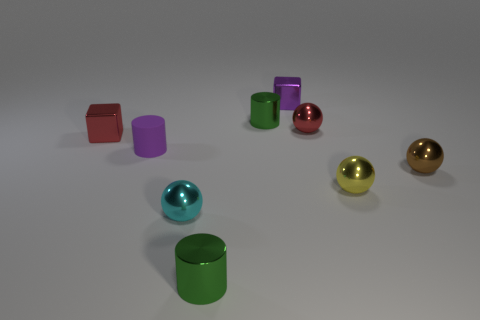Does the small matte object have the same color as the small ball behind the purple cylinder?
Provide a short and direct response. No. What color is the small ball that is in front of the brown ball and left of the yellow object?
Give a very brief answer. Cyan. There is a purple metal cube; what number of small red metal things are behind it?
Provide a short and direct response. 0. How many things are either large blocks or red spheres behind the cyan sphere?
Your answer should be compact. 1. Is there a small green object in front of the tiny cyan thing in front of the small rubber cylinder?
Keep it short and to the point. Yes. What is the color of the tiny cylinder that is in front of the tiny brown sphere?
Your response must be concise. Green. Is the number of tiny brown objects behind the small matte cylinder the same as the number of red metal things?
Your response must be concise. No. There is a small metal thing that is behind the brown metallic thing and in front of the tiny red metallic sphere; what is its shape?
Provide a succinct answer. Cube. There is another small metal object that is the same shape as the small purple metallic thing; what color is it?
Offer a terse response. Red. There is a small red thing left of the small block behind the green object that is behind the brown metal ball; what is its shape?
Give a very brief answer. Cube. 